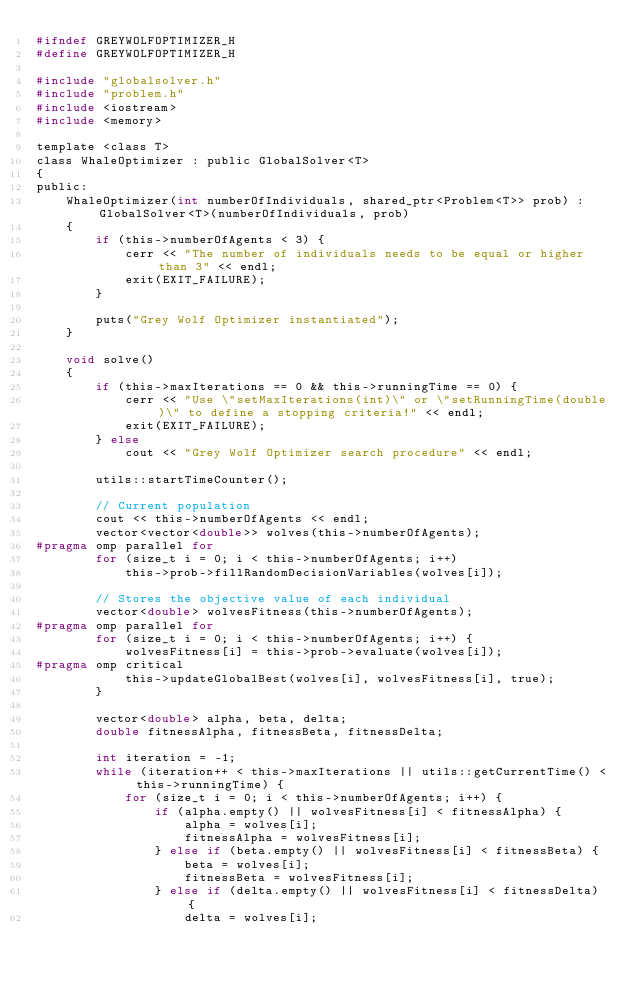<code> <loc_0><loc_0><loc_500><loc_500><_C_>#ifndef GREYWOLFOPTIMIZER_H
#define GREYWOLFOPTIMIZER_H

#include "globalsolver.h"
#include "problem.h"
#include <iostream>
#include <memory>

template <class T>
class WhaleOptimizer : public GlobalSolver<T>
{
public:
    WhaleOptimizer(int numberOfIndividuals, shared_ptr<Problem<T>> prob) : GlobalSolver<T>(numberOfIndividuals, prob)
    {
        if (this->numberOfAgents < 3) {
            cerr << "The number of individuals needs to be equal or higher than 3" << endl;
            exit(EXIT_FAILURE);
        }

        puts("Grey Wolf Optimizer instantiated");
    }

    void solve()
    {
        if (this->maxIterations == 0 && this->runningTime == 0) {
            cerr << "Use \"setMaxIterations(int)\" or \"setRunningTime(double)\" to define a stopping criteria!" << endl;
            exit(EXIT_FAILURE);
        } else
            cout << "Grey Wolf Optimizer search procedure" << endl;

        utils::startTimeCounter();

        // Current population
        cout << this->numberOfAgents << endl;
        vector<vector<double>> wolves(this->numberOfAgents);
#pragma omp parallel for
        for (size_t i = 0; i < this->numberOfAgents; i++)
            this->prob->fillRandomDecisionVariables(wolves[i]);

        // Stores the objective value of each individual
        vector<double> wolvesFitness(this->numberOfAgents);
#pragma omp parallel for
        for (size_t i = 0; i < this->numberOfAgents; i++) {
            wolvesFitness[i] = this->prob->evaluate(wolves[i]);
#pragma omp critical
            this->updateGlobalBest(wolves[i], wolvesFitness[i], true);
        }

        vector<double> alpha, beta, delta;
        double fitnessAlpha, fitnessBeta, fitnessDelta;

        int iteration = -1;
        while (iteration++ < this->maxIterations || utils::getCurrentTime() < this->runningTime) {
            for (size_t i = 0; i < this->numberOfAgents; i++) {
                if (alpha.empty() || wolvesFitness[i] < fitnessAlpha) {
                    alpha = wolves[i];
                    fitnessAlpha = wolvesFitness[i];
                } else if (beta.empty() || wolvesFitness[i] < fitnessBeta) {
                    beta = wolves[i];
                    fitnessBeta = wolvesFitness[i];
                } else if (delta.empty() || wolvesFitness[i] < fitnessDelta) {
                    delta = wolves[i];</code> 